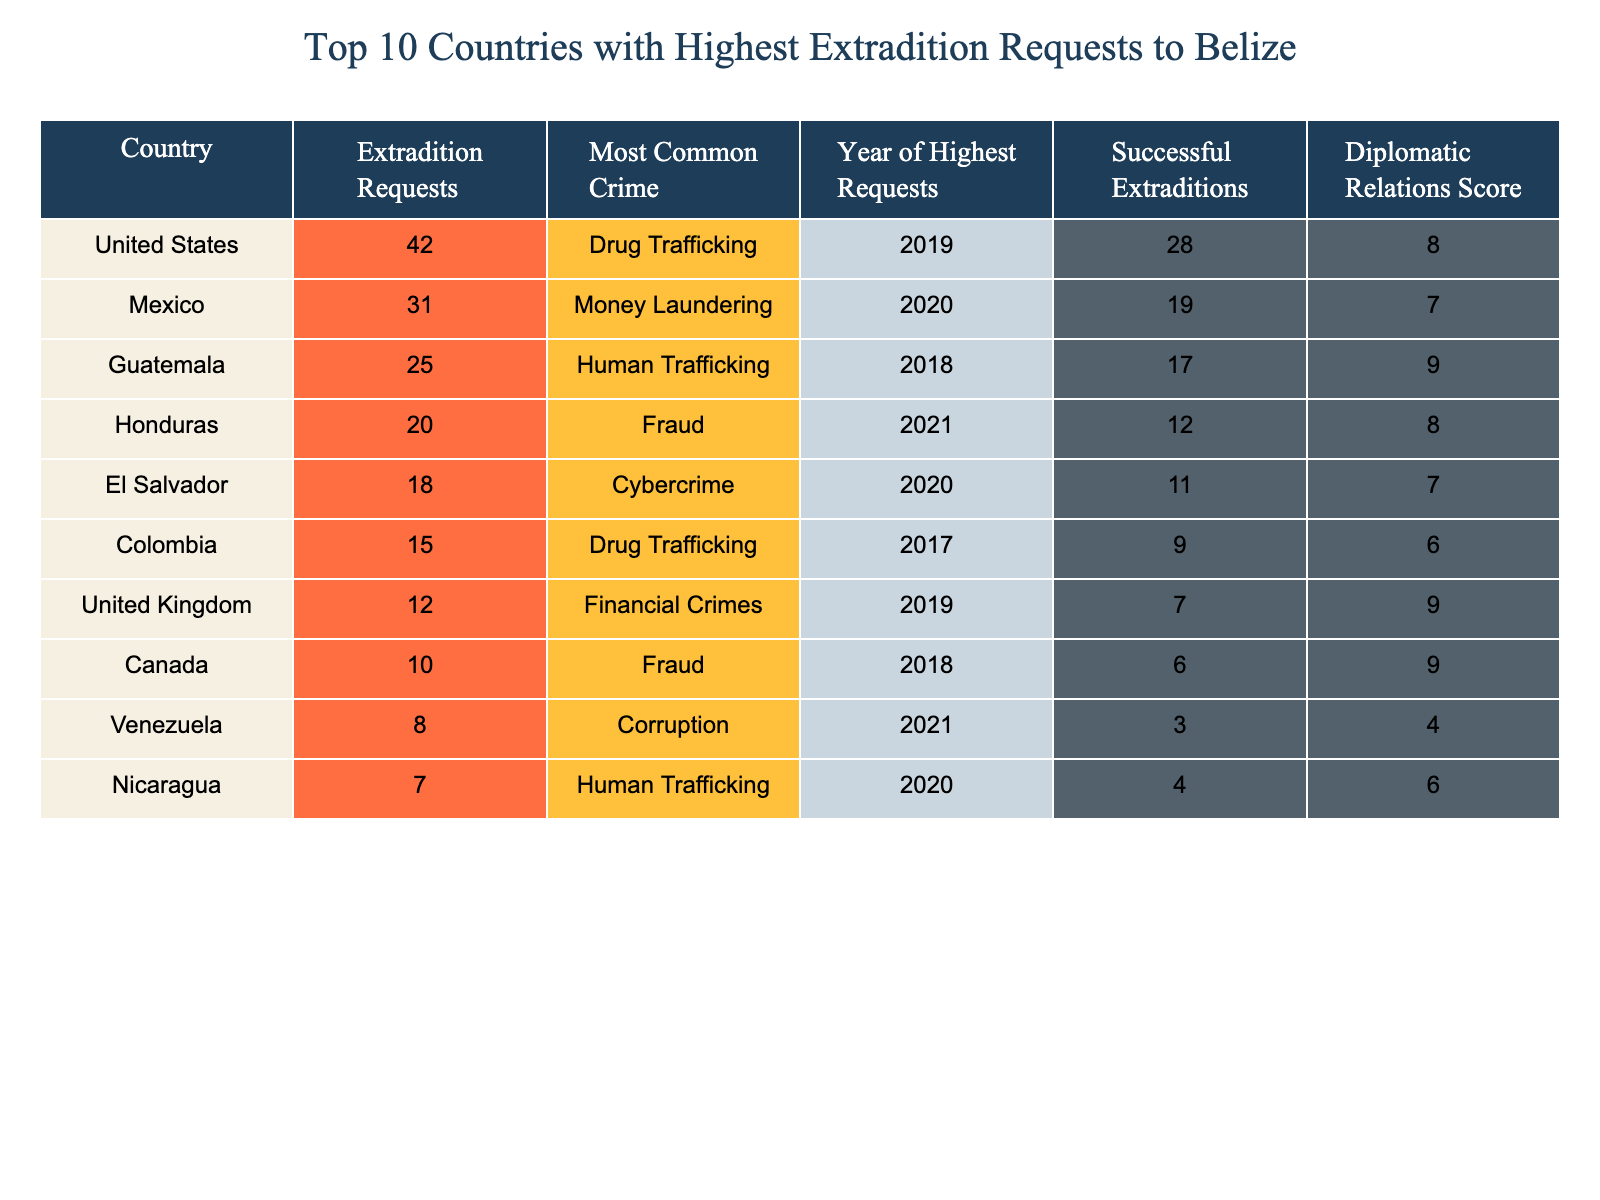What country had the highest number of extradition requests to Belize? The table indicates that the United States had the highest number of extradition requests, with a total of 42 requests.
Answer: United States What was the most common crime associated with extradition requests from Mexico? According to the table, the most common crime for extradition requests from Mexico was money laundering.
Answer: Money Laundering How many successful extraditions were made from Guatemala? The table shows that there were 17 successful extraditions made from Guatemala.
Answer: 17 Which country had the least number of extradition requests to Belize? From the table, Nicaragua is shown to have the least number of extradition requests, with a total of 7.
Answer: Nicaragua What is the average number of extradition requests from the top three countries? Adding the extradition requests from the top three countries: United States (42) + Mexico (31) + Guatemala (25) = 98. Dividing by 3 gives an average of 32.67.
Answer: 32.67 Did Colombia have more successful extraditions than Venezuela? According to the table, Colombia had 9 successful extraditions, whereas Venezuela had only 3. Therefore, Colombia did have more successful extraditions than Venezuela.
Answer: Yes Which country had the highest number of successful extraditions in 2021? Looking at the table, Honduras had the highest number of successful extraditions in 2021 with a total of 12.
Answer: Honduras What was the diplomatic relations score for Canada? The table indicates that Canada has a diplomatic relations score of 9.
Answer: 9 Which countries had a diplomatic relations score of 7 or lower? From the table, Mexico, El Salvador, and Venezuela had diplomatic relations scores of 7, 7, and 4 respectively.
Answer: Mexico, El Salvador, Venezuela What is the difference in extradition requests between the United States and Colombia? The United States had 42 extradition requests and Colombia had 15. The difference is 42 - 15 = 27.
Answer: 27 How many countries had drug trafficking as the most common crime associated with extradition requests? The table shows that two countries, the United States and Colombia, listed drug trafficking as the most common crime for their extradition requests.
Answer: 2 